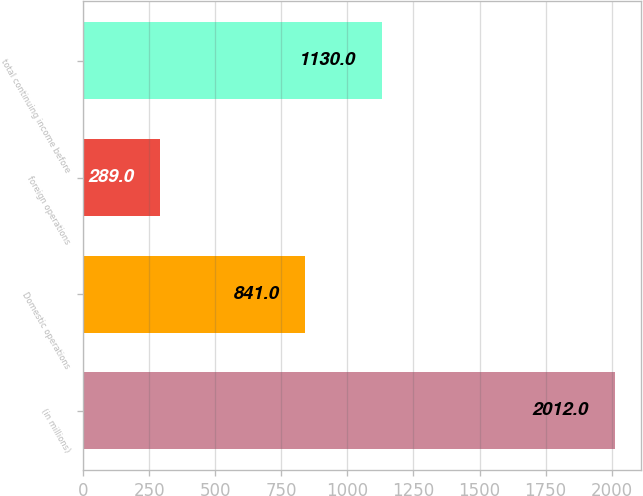<chart> <loc_0><loc_0><loc_500><loc_500><bar_chart><fcel>(in millions)<fcel>Domestic operations<fcel>foreign operations<fcel>total continuing income before<nl><fcel>2012<fcel>841<fcel>289<fcel>1130<nl></chart> 